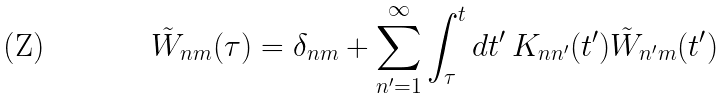Convert formula to latex. <formula><loc_0><loc_0><loc_500><loc_500>\tilde { W } _ { n m } ( \tau ) = \delta _ { n m } + \sum ^ { \infty } _ { n ^ { \prime } = 1 } \int _ { \tau } ^ { t } d t ^ { \prime } \, K _ { n n ^ { \prime } } ( t ^ { \prime } ) \tilde { W } _ { n ^ { \prime } m } ( t ^ { \prime } )</formula> 